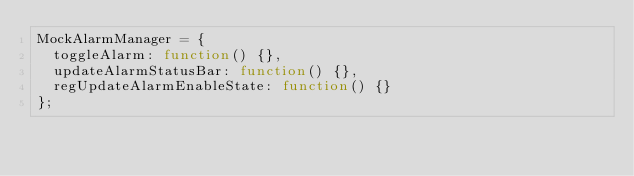Convert code to text. <code><loc_0><loc_0><loc_500><loc_500><_JavaScript_>MockAlarmManager = {
  toggleAlarm: function() {},
  updateAlarmStatusBar: function() {},
  regUpdateAlarmEnableState: function() {}
};
</code> 